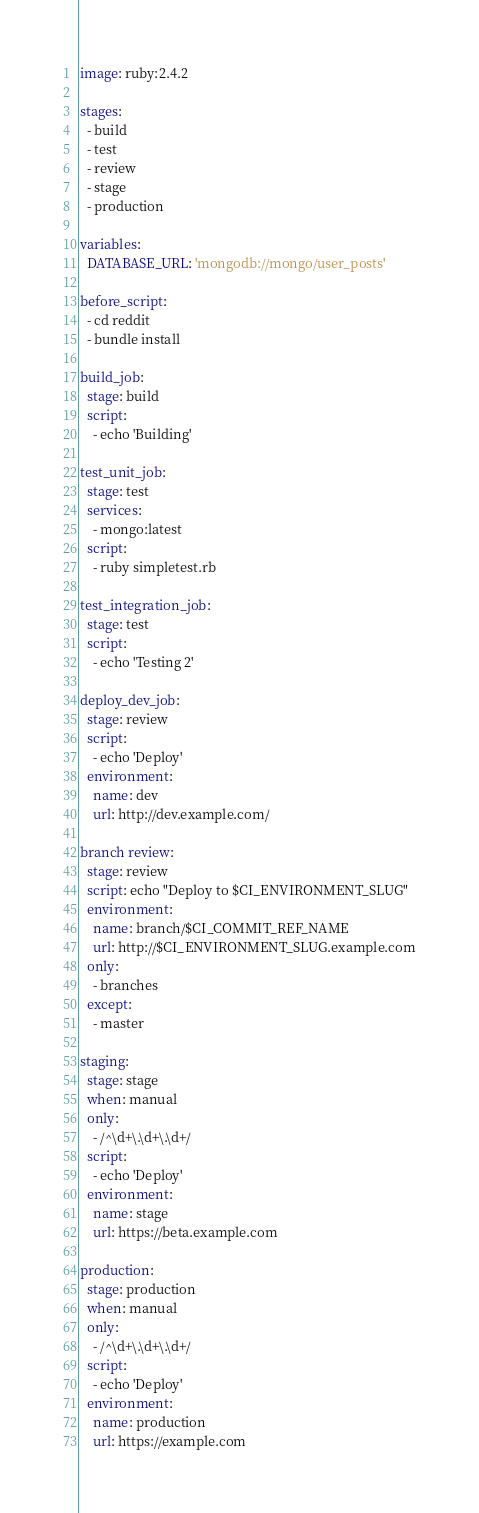<code> <loc_0><loc_0><loc_500><loc_500><_YAML_>image: ruby:2.4.2

stages:
  - build
  - test
  - review
  - stage
  - production

variables:
  DATABASE_URL: 'mongodb://mongo/user_posts'

before_script:
  - cd reddit
  - bundle install

build_job:
  stage: build
  script:
    - echo 'Building'

test_unit_job:
  stage: test
  services:
    - mongo:latest
  script:
    - ruby simpletest.rb

test_integration_job:
  stage: test
  script:
    - echo 'Testing 2'

deploy_dev_job:
  stage: review
  script:
    - echo 'Deploy'
  environment:
    name: dev
    url: http://dev.example.com/

branch review:
  stage: review
  script: echo "Deploy to $CI_ENVIRONMENT_SLUG"
  environment:
    name: branch/$CI_COMMIT_REF_NAME
    url: http://$CI_ENVIRONMENT_SLUG.example.com
  only:
    - branches
  except:
    - master   

staging:
  stage: stage
  when: manual
  only:
    - /^\d+\.\d+\.\d+/
  script:
    - echo 'Deploy'
  environment:
    name: stage
    url: https://beta.example.com

production:
  stage: production
  when: manual
  only:
    - /^\d+\.\d+\.\d+/
  script:
    - echo 'Deploy'
  environment:
    name: production
    url: https://example.com
</code> 